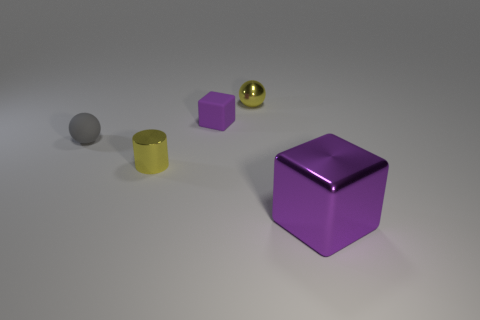What is the thing that is on the right side of the yellow ball made of?
Make the answer very short. Metal. There is a purple cube that is behind the thing that is left of the small yellow object in front of the small block; what is its size?
Your response must be concise. Small. Is the large thing that is in front of the small purple matte block made of the same material as the tiny object left of the yellow cylinder?
Give a very brief answer. No. What number of other objects are the same color as the small block?
Your answer should be compact. 1. How many things are shiny things left of the large shiny object or purple blocks that are to the left of the metallic sphere?
Your answer should be compact. 3. There is a sphere that is to the left of the yellow object that is behind the gray rubber ball; what size is it?
Your answer should be compact. Small. What size is the shiny ball?
Your answer should be compact. Small. There is a cube behind the shiny block; is it the same color as the tiny shiny cylinder behind the big purple thing?
Your answer should be compact. No. What number of other objects are there of the same material as the tiny yellow sphere?
Offer a very short reply. 2. Are there any cyan cubes?
Keep it short and to the point. No. 